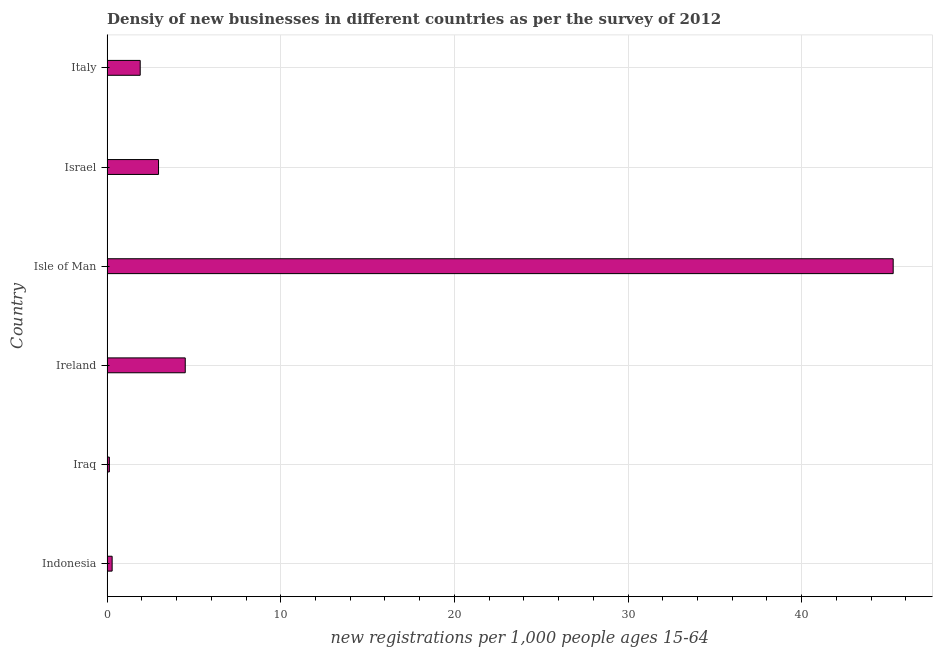Does the graph contain grids?
Your answer should be very brief. Yes. What is the title of the graph?
Keep it short and to the point. Densiy of new businesses in different countries as per the survey of 2012. What is the label or title of the X-axis?
Offer a very short reply. New registrations per 1,0 people ages 15-64. What is the density of new business in Indonesia?
Your response must be concise. 0.29. Across all countries, what is the maximum density of new business?
Your response must be concise. 45.27. Across all countries, what is the minimum density of new business?
Your answer should be very brief. 0.13. In which country was the density of new business maximum?
Make the answer very short. Isle of Man. In which country was the density of new business minimum?
Offer a terse response. Iraq. What is the sum of the density of new business?
Ensure brevity in your answer.  55.06. What is the difference between the density of new business in Isle of Man and Israel?
Provide a short and direct response. 42.31. What is the average density of new business per country?
Your response must be concise. 9.18. What is the median density of new business?
Give a very brief answer. 2.43. In how many countries, is the density of new business greater than 26 ?
Your answer should be compact. 1. What is the ratio of the density of new business in Ireland to that in Israel?
Offer a terse response. 1.52. What is the difference between the highest and the second highest density of new business?
Ensure brevity in your answer.  40.77. Is the sum of the density of new business in Iraq and Ireland greater than the maximum density of new business across all countries?
Ensure brevity in your answer.  No. What is the difference between the highest and the lowest density of new business?
Provide a succinct answer. 45.14. In how many countries, is the density of new business greater than the average density of new business taken over all countries?
Your answer should be very brief. 1. How many countries are there in the graph?
Offer a terse response. 6. What is the difference between two consecutive major ticks on the X-axis?
Ensure brevity in your answer.  10. What is the new registrations per 1,000 people ages 15-64 of Indonesia?
Ensure brevity in your answer.  0.29. What is the new registrations per 1,000 people ages 15-64 of Iraq?
Provide a succinct answer. 0.13. What is the new registrations per 1,000 people ages 15-64 of Ireland?
Ensure brevity in your answer.  4.5. What is the new registrations per 1,000 people ages 15-64 of Isle of Man?
Your response must be concise. 45.27. What is the new registrations per 1,000 people ages 15-64 in Israel?
Offer a terse response. 2.96. What is the new registrations per 1,000 people ages 15-64 of Italy?
Offer a very short reply. 1.91. What is the difference between the new registrations per 1,000 people ages 15-64 in Indonesia and Iraq?
Give a very brief answer. 0.16. What is the difference between the new registrations per 1,000 people ages 15-64 in Indonesia and Ireland?
Make the answer very short. -4.21. What is the difference between the new registrations per 1,000 people ages 15-64 in Indonesia and Isle of Man?
Offer a terse response. -44.98. What is the difference between the new registrations per 1,000 people ages 15-64 in Indonesia and Israel?
Keep it short and to the point. -2.67. What is the difference between the new registrations per 1,000 people ages 15-64 in Indonesia and Italy?
Your answer should be very brief. -1.62. What is the difference between the new registrations per 1,000 people ages 15-64 in Iraq and Ireland?
Give a very brief answer. -4.37. What is the difference between the new registrations per 1,000 people ages 15-64 in Iraq and Isle of Man?
Your response must be concise. -45.14. What is the difference between the new registrations per 1,000 people ages 15-64 in Iraq and Israel?
Provide a succinct answer. -2.83. What is the difference between the new registrations per 1,000 people ages 15-64 in Iraq and Italy?
Offer a very short reply. -1.78. What is the difference between the new registrations per 1,000 people ages 15-64 in Ireland and Isle of Man?
Give a very brief answer. -40.77. What is the difference between the new registrations per 1,000 people ages 15-64 in Ireland and Israel?
Your answer should be very brief. 1.54. What is the difference between the new registrations per 1,000 people ages 15-64 in Ireland and Italy?
Provide a succinct answer. 2.59. What is the difference between the new registrations per 1,000 people ages 15-64 in Isle of Man and Israel?
Your response must be concise. 42.31. What is the difference between the new registrations per 1,000 people ages 15-64 in Isle of Man and Italy?
Provide a succinct answer. 43.36. What is the difference between the new registrations per 1,000 people ages 15-64 in Israel and Italy?
Keep it short and to the point. 1.06. What is the ratio of the new registrations per 1,000 people ages 15-64 in Indonesia to that in Iraq?
Offer a very short reply. 2.23. What is the ratio of the new registrations per 1,000 people ages 15-64 in Indonesia to that in Ireland?
Provide a succinct answer. 0.06. What is the ratio of the new registrations per 1,000 people ages 15-64 in Indonesia to that in Isle of Man?
Provide a short and direct response. 0.01. What is the ratio of the new registrations per 1,000 people ages 15-64 in Indonesia to that in Israel?
Your answer should be very brief. 0.1. What is the ratio of the new registrations per 1,000 people ages 15-64 in Indonesia to that in Italy?
Provide a succinct answer. 0.15. What is the ratio of the new registrations per 1,000 people ages 15-64 in Iraq to that in Ireland?
Keep it short and to the point. 0.03. What is the ratio of the new registrations per 1,000 people ages 15-64 in Iraq to that in Isle of Man?
Offer a very short reply. 0. What is the ratio of the new registrations per 1,000 people ages 15-64 in Iraq to that in Israel?
Your answer should be compact. 0.04. What is the ratio of the new registrations per 1,000 people ages 15-64 in Iraq to that in Italy?
Offer a very short reply. 0.07. What is the ratio of the new registrations per 1,000 people ages 15-64 in Ireland to that in Isle of Man?
Offer a terse response. 0.1. What is the ratio of the new registrations per 1,000 people ages 15-64 in Ireland to that in Israel?
Provide a short and direct response. 1.52. What is the ratio of the new registrations per 1,000 people ages 15-64 in Ireland to that in Italy?
Provide a short and direct response. 2.36. What is the ratio of the new registrations per 1,000 people ages 15-64 in Isle of Man to that in Israel?
Your answer should be compact. 15.29. What is the ratio of the new registrations per 1,000 people ages 15-64 in Isle of Man to that in Italy?
Give a very brief answer. 23.75. What is the ratio of the new registrations per 1,000 people ages 15-64 in Israel to that in Italy?
Provide a succinct answer. 1.55. 